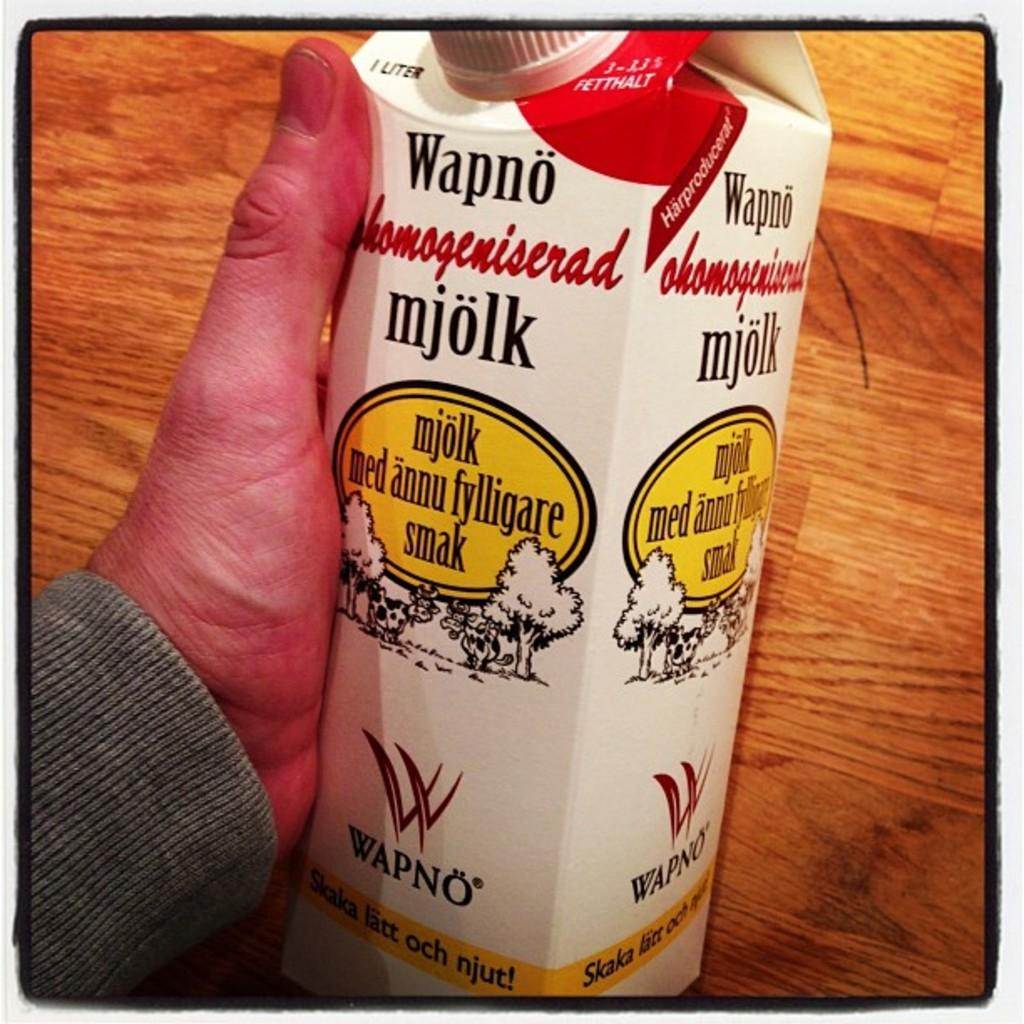What is the person's hand holding in the image? The person's hand is holding an object in the image. Can you describe the object being held? The object has text and images on it. What is visible in the background of the image? There is a table in the background of the image. What type of fuel is the person using to attack the crook in the image? There is no fuel, attack, or crook present in the image. 